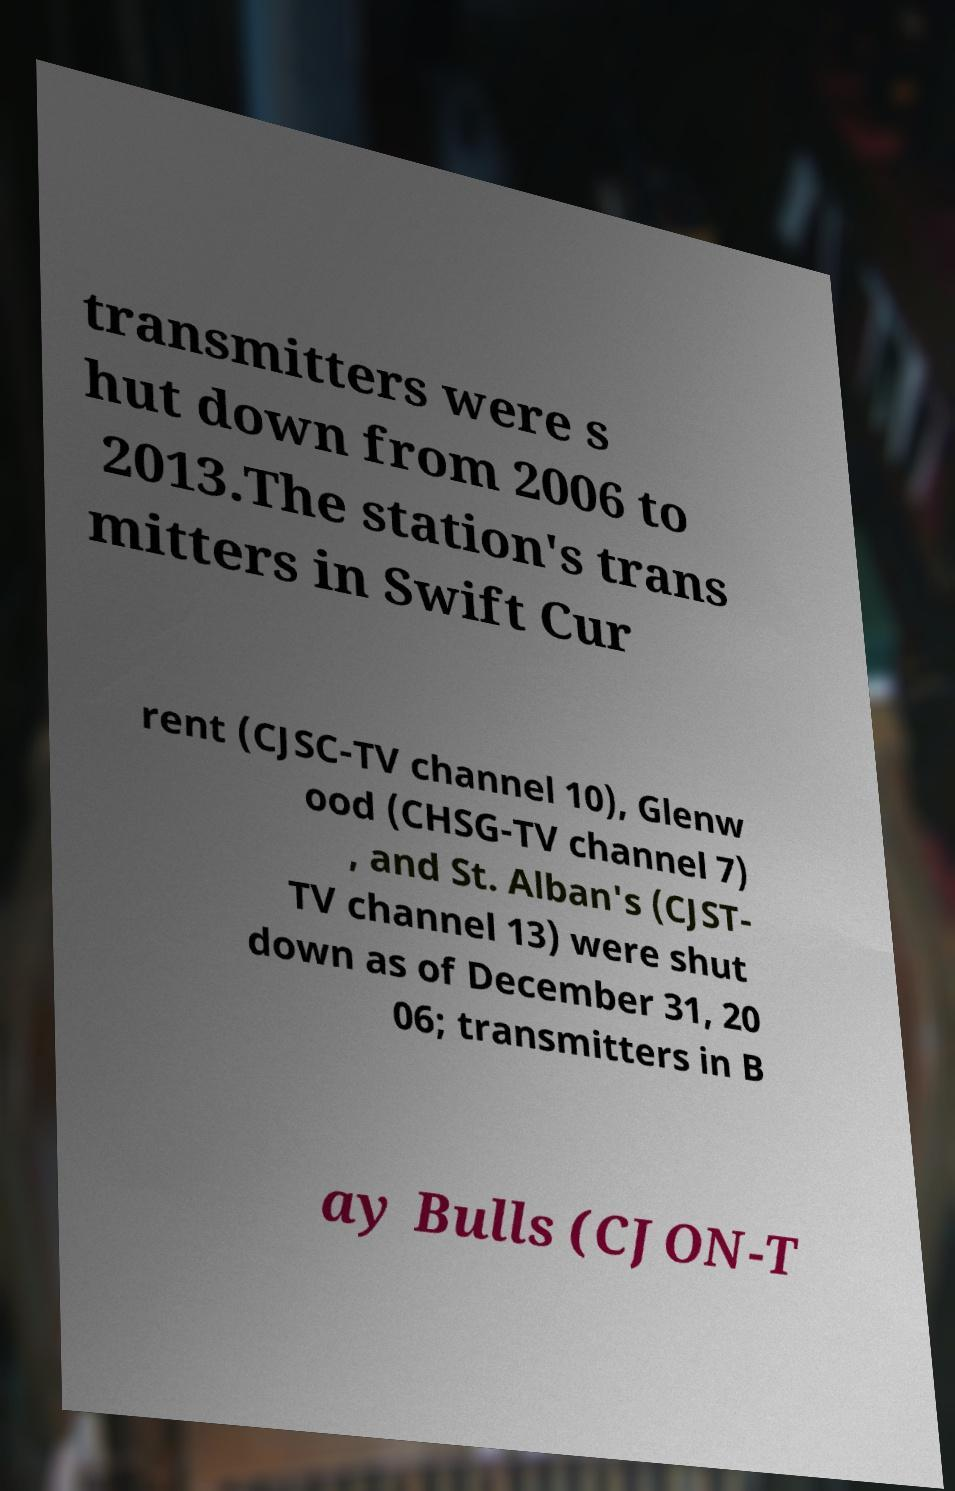Could you extract and type out the text from this image? transmitters were s hut down from 2006 to 2013.The station's trans mitters in Swift Cur rent (CJSC-TV channel 10), Glenw ood (CHSG-TV channel 7) , and St. Alban's (CJST- TV channel 13) were shut down as of December 31, 20 06; transmitters in B ay Bulls (CJON-T 